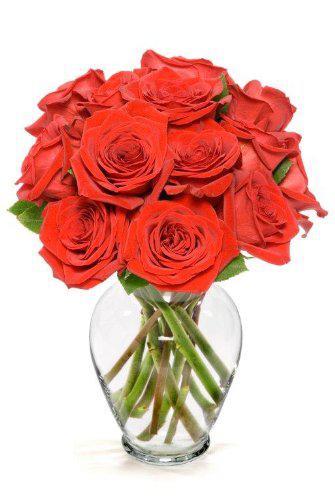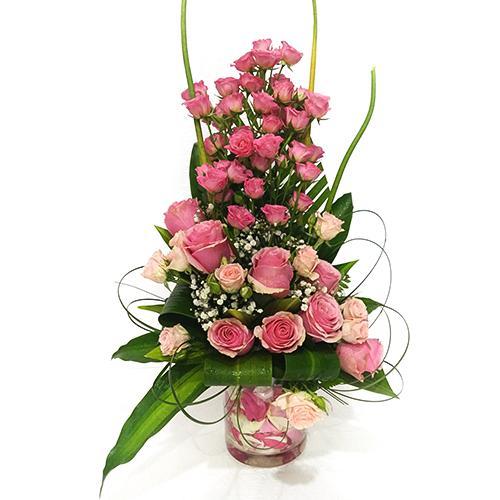The first image is the image on the left, the second image is the image on the right. Assess this claim about the two images: "No vase includes only roses, and at least one vase is decorated with a ribbon tied in a bow.". Correct or not? Answer yes or no. No. 